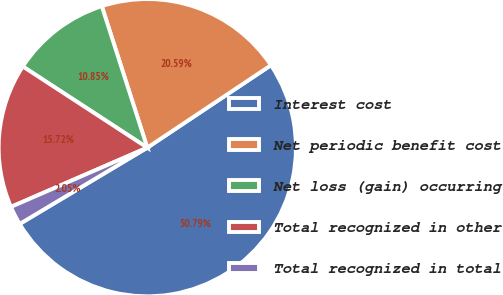Convert chart to OTSL. <chart><loc_0><loc_0><loc_500><loc_500><pie_chart><fcel>Interest cost<fcel>Net periodic benefit cost<fcel>Net loss (gain) occurring<fcel>Total recognized in other<fcel>Total recognized in total<nl><fcel>50.78%<fcel>20.59%<fcel>10.85%<fcel>15.72%<fcel>2.05%<nl></chart> 